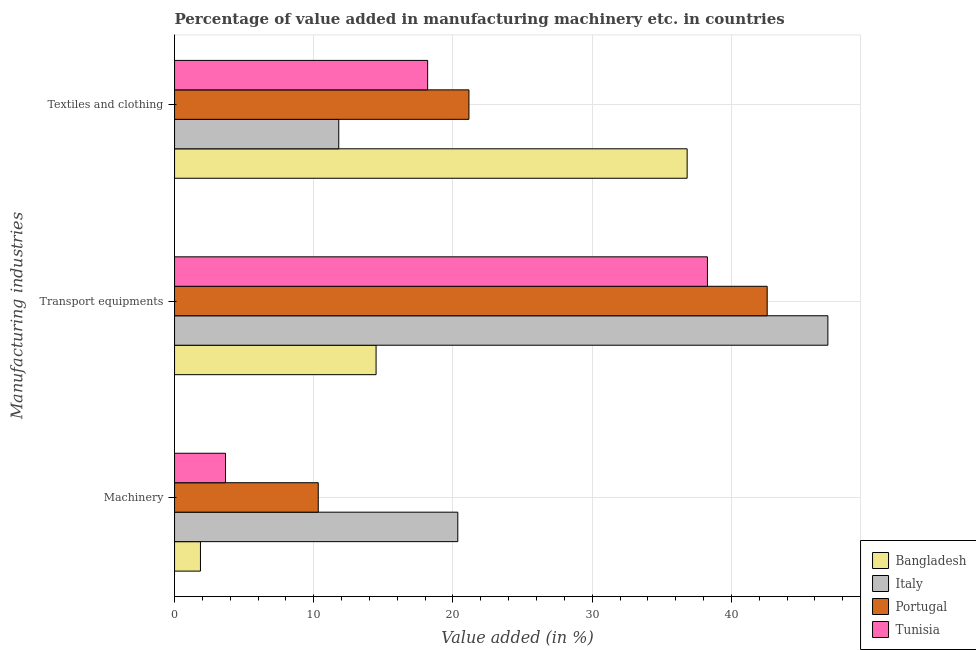How many different coloured bars are there?
Provide a succinct answer. 4. How many bars are there on the 1st tick from the top?
Keep it short and to the point. 4. How many bars are there on the 3rd tick from the bottom?
Provide a short and direct response. 4. What is the label of the 3rd group of bars from the top?
Make the answer very short. Machinery. What is the value added in manufacturing transport equipments in Italy?
Your answer should be very brief. 46.93. Across all countries, what is the maximum value added in manufacturing textile and clothing?
Give a very brief answer. 36.82. Across all countries, what is the minimum value added in manufacturing transport equipments?
Make the answer very short. 14.48. In which country was the value added in manufacturing machinery maximum?
Offer a very short reply. Italy. In which country was the value added in manufacturing textile and clothing minimum?
Give a very brief answer. Italy. What is the total value added in manufacturing textile and clothing in the graph?
Make the answer very short. 87.94. What is the difference between the value added in manufacturing transport equipments in Italy and that in Tunisia?
Offer a very short reply. 8.65. What is the difference between the value added in manufacturing machinery in Italy and the value added in manufacturing transport equipments in Tunisia?
Offer a terse response. -17.93. What is the average value added in manufacturing textile and clothing per country?
Provide a succinct answer. 21.98. What is the difference between the value added in manufacturing machinery and value added in manufacturing transport equipments in Italy?
Offer a very short reply. -26.58. What is the ratio of the value added in manufacturing machinery in Italy to that in Tunisia?
Give a very brief answer. 5.56. Is the value added in manufacturing machinery in Portugal less than that in Bangladesh?
Give a very brief answer. No. What is the difference between the highest and the second highest value added in manufacturing transport equipments?
Make the answer very short. 4.36. What is the difference between the highest and the lowest value added in manufacturing machinery?
Your response must be concise. 18.48. In how many countries, is the value added in manufacturing textile and clothing greater than the average value added in manufacturing textile and clothing taken over all countries?
Offer a very short reply. 1. What does the 2nd bar from the top in Textiles and clothing represents?
Provide a short and direct response. Portugal. What does the 4th bar from the bottom in Textiles and clothing represents?
Provide a succinct answer. Tunisia. Is it the case that in every country, the sum of the value added in manufacturing machinery and value added in manufacturing transport equipments is greater than the value added in manufacturing textile and clothing?
Your answer should be very brief. No. How many countries are there in the graph?
Offer a terse response. 4. Does the graph contain grids?
Offer a terse response. Yes. How many legend labels are there?
Ensure brevity in your answer.  4. What is the title of the graph?
Your answer should be compact. Percentage of value added in manufacturing machinery etc. in countries. Does "Seychelles" appear as one of the legend labels in the graph?
Provide a succinct answer. No. What is the label or title of the X-axis?
Offer a terse response. Value added (in %). What is the label or title of the Y-axis?
Provide a succinct answer. Manufacturing industries. What is the Value added (in %) in Bangladesh in Machinery?
Offer a very short reply. 1.86. What is the Value added (in %) of Italy in Machinery?
Provide a short and direct response. 20.34. What is the Value added (in %) of Portugal in Machinery?
Your response must be concise. 10.32. What is the Value added (in %) in Tunisia in Machinery?
Make the answer very short. 3.66. What is the Value added (in %) of Bangladesh in Transport equipments?
Provide a short and direct response. 14.48. What is the Value added (in %) of Italy in Transport equipments?
Provide a short and direct response. 46.93. What is the Value added (in %) of Portugal in Transport equipments?
Your answer should be compact. 42.57. What is the Value added (in %) in Tunisia in Transport equipments?
Offer a very short reply. 38.28. What is the Value added (in %) of Bangladesh in Textiles and clothing?
Your answer should be compact. 36.82. What is the Value added (in %) of Italy in Textiles and clothing?
Ensure brevity in your answer.  11.79. What is the Value added (in %) in Portugal in Textiles and clothing?
Your answer should be compact. 21.15. What is the Value added (in %) in Tunisia in Textiles and clothing?
Ensure brevity in your answer.  18.18. Across all Manufacturing industries, what is the maximum Value added (in %) in Bangladesh?
Offer a very short reply. 36.82. Across all Manufacturing industries, what is the maximum Value added (in %) of Italy?
Provide a short and direct response. 46.93. Across all Manufacturing industries, what is the maximum Value added (in %) of Portugal?
Keep it short and to the point. 42.57. Across all Manufacturing industries, what is the maximum Value added (in %) of Tunisia?
Offer a terse response. 38.28. Across all Manufacturing industries, what is the minimum Value added (in %) in Bangladesh?
Provide a succinct answer. 1.86. Across all Manufacturing industries, what is the minimum Value added (in %) in Italy?
Keep it short and to the point. 11.79. Across all Manufacturing industries, what is the minimum Value added (in %) in Portugal?
Offer a very short reply. 10.32. Across all Manufacturing industries, what is the minimum Value added (in %) in Tunisia?
Provide a succinct answer. 3.66. What is the total Value added (in %) of Bangladesh in the graph?
Your response must be concise. 53.15. What is the total Value added (in %) of Italy in the graph?
Ensure brevity in your answer.  79.07. What is the total Value added (in %) of Portugal in the graph?
Ensure brevity in your answer.  74.04. What is the total Value added (in %) of Tunisia in the graph?
Your response must be concise. 60.12. What is the difference between the Value added (in %) in Bangladesh in Machinery and that in Transport equipments?
Offer a terse response. -12.62. What is the difference between the Value added (in %) in Italy in Machinery and that in Transport equipments?
Your answer should be compact. -26.58. What is the difference between the Value added (in %) in Portugal in Machinery and that in Transport equipments?
Give a very brief answer. -32.25. What is the difference between the Value added (in %) in Tunisia in Machinery and that in Transport equipments?
Offer a terse response. -34.61. What is the difference between the Value added (in %) in Bangladesh in Machinery and that in Textiles and clothing?
Offer a terse response. -34.96. What is the difference between the Value added (in %) of Italy in Machinery and that in Textiles and clothing?
Offer a terse response. 8.55. What is the difference between the Value added (in %) of Portugal in Machinery and that in Textiles and clothing?
Keep it short and to the point. -10.82. What is the difference between the Value added (in %) of Tunisia in Machinery and that in Textiles and clothing?
Your answer should be very brief. -14.52. What is the difference between the Value added (in %) in Bangladesh in Transport equipments and that in Textiles and clothing?
Keep it short and to the point. -22.34. What is the difference between the Value added (in %) of Italy in Transport equipments and that in Textiles and clothing?
Ensure brevity in your answer.  35.13. What is the difference between the Value added (in %) in Portugal in Transport equipments and that in Textiles and clothing?
Keep it short and to the point. 21.42. What is the difference between the Value added (in %) of Tunisia in Transport equipments and that in Textiles and clothing?
Keep it short and to the point. 20.1. What is the difference between the Value added (in %) of Bangladesh in Machinery and the Value added (in %) of Italy in Transport equipments?
Offer a very short reply. -45.07. What is the difference between the Value added (in %) in Bangladesh in Machinery and the Value added (in %) in Portugal in Transport equipments?
Offer a terse response. -40.71. What is the difference between the Value added (in %) of Bangladesh in Machinery and the Value added (in %) of Tunisia in Transport equipments?
Your answer should be very brief. -36.42. What is the difference between the Value added (in %) of Italy in Machinery and the Value added (in %) of Portugal in Transport equipments?
Give a very brief answer. -22.22. What is the difference between the Value added (in %) in Italy in Machinery and the Value added (in %) in Tunisia in Transport equipments?
Keep it short and to the point. -17.93. What is the difference between the Value added (in %) of Portugal in Machinery and the Value added (in %) of Tunisia in Transport equipments?
Offer a very short reply. -27.95. What is the difference between the Value added (in %) in Bangladesh in Machinery and the Value added (in %) in Italy in Textiles and clothing?
Give a very brief answer. -9.93. What is the difference between the Value added (in %) in Bangladesh in Machinery and the Value added (in %) in Portugal in Textiles and clothing?
Keep it short and to the point. -19.29. What is the difference between the Value added (in %) in Bangladesh in Machinery and the Value added (in %) in Tunisia in Textiles and clothing?
Ensure brevity in your answer.  -16.32. What is the difference between the Value added (in %) in Italy in Machinery and the Value added (in %) in Portugal in Textiles and clothing?
Make the answer very short. -0.8. What is the difference between the Value added (in %) in Italy in Machinery and the Value added (in %) in Tunisia in Textiles and clothing?
Provide a succinct answer. 2.17. What is the difference between the Value added (in %) of Portugal in Machinery and the Value added (in %) of Tunisia in Textiles and clothing?
Give a very brief answer. -7.86. What is the difference between the Value added (in %) of Bangladesh in Transport equipments and the Value added (in %) of Italy in Textiles and clothing?
Ensure brevity in your answer.  2.68. What is the difference between the Value added (in %) of Bangladesh in Transport equipments and the Value added (in %) of Portugal in Textiles and clothing?
Ensure brevity in your answer.  -6.67. What is the difference between the Value added (in %) of Bangladesh in Transport equipments and the Value added (in %) of Tunisia in Textiles and clothing?
Make the answer very short. -3.7. What is the difference between the Value added (in %) in Italy in Transport equipments and the Value added (in %) in Portugal in Textiles and clothing?
Offer a terse response. 25.78. What is the difference between the Value added (in %) of Italy in Transport equipments and the Value added (in %) of Tunisia in Textiles and clothing?
Keep it short and to the point. 28.75. What is the difference between the Value added (in %) in Portugal in Transport equipments and the Value added (in %) in Tunisia in Textiles and clothing?
Provide a succinct answer. 24.39. What is the average Value added (in %) of Bangladesh per Manufacturing industries?
Provide a succinct answer. 17.72. What is the average Value added (in %) in Italy per Manufacturing industries?
Make the answer very short. 26.36. What is the average Value added (in %) in Portugal per Manufacturing industries?
Keep it short and to the point. 24.68. What is the average Value added (in %) in Tunisia per Manufacturing industries?
Make the answer very short. 20.04. What is the difference between the Value added (in %) in Bangladesh and Value added (in %) in Italy in Machinery?
Your answer should be compact. -18.48. What is the difference between the Value added (in %) of Bangladesh and Value added (in %) of Portugal in Machinery?
Your response must be concise. -8.46. What is the difference between the Value added (in %) in Bangladesh and Value added (in %) in Tunisia in Machinery?
Offer a terse response. -1.8. What is the difference between the Value added (in %) of Italy and Value added (in %) of Portugal in Machinery?
Your answer should be compact. 10.02. What is the difference between the Value added (in %) of Italy and Value added (in %) of Tunisia in Machinery?
Your response must be concise. 16.68. What is the difference between the Value added (in %) in Portugal and Value added (in %) in Tunisia in Machinery?
Your answer should be compact. 6.66. What is the difference between the Value added (in %) of Bangladesh and Value added (in %) of Italy in Transport equipments?
Make the answer very short. -32.45. What is the difference between the Value added (in %) of Bangladesh and Value added (in %) of Portugal in Transport equipments?
Your answer should be very brief. -28.09. What is the difference between the Value added (in %) of Bangladesh and Value added (in %) of Tunisia in Transport equipments?
Your answer should be compact. -23.8. What is the difference between the Value added (in %) of Italy and Value added (in %) of Portugal in Transport equipments?
Keep it short and to the point. 4.36. What is the difference between the Value added (in %) of Italy and Value added (in %) of Tunisia in Transport equipments?
Your answer should be very brief. 8.65. What is the difference between the Value added (in %) in Portugal and Value added (in %) in Tunisia in Transport equipments?
Make the answer very short. 4.29. What is the difference between the Value added (in %) of Bangladesh and Value added (in %) of Italy in Textiles and clothing?
Provide a succinct answer. 25.02. What is the difference between the Value added (in %) of Bangladesh and Value added (in %) of Portugal in Textiles and clothing?
Give a very brief answer. 15.67. What is the difference between the Value added (in %) of Bangladesh and Value added (in %) of Tunisia in Textiles and clothing?
Your answer should be compact. 18.64. What is the difference between the Value added (in %) in Italy and Value added (in %) in Portugal in Textiles and clothing?
Offer a terse response. -9.35. What is the difference between the Value added (in %) of Italy and Value added (in %) of Tunisia in Textiles and clothing?
Your answer should be very brief. -6.38. What is the difference between the Value added (in %) of Portugal and Value added (in %) of Tunisia in Textiles and clothing?
Ensure brevity in your answer.  2.97. What is the ratio of the Value added (in %) in Bangladesh in Machinery to that in Transport equipments?
Give a very brief answer. 0.13. What is the ratio of the Value added (in %) of Italy in Machinery to that in Transport equipments?
Offer a terse response. 0.43. What is the ratio of the Value added (in %) in Portugal in Machinery to that in Transport equipments?
Your response must be concise. 0.24. What is the ratio of the Value added (in %) of Tunisia in Machinery to that in Transport equipments?
Give a very brief answer. 0.1. What is the ratio of the Value added (in %) of Bangladesh in Machinery to that in Textiles and clothing?
Ensure brevity in your answer.  0.05. What is the ratio of the Value added (in %) in Italy in Machinery to that in Textiles and clothing?
Offer a terse response. 1.73. What is the ratio of the Value added (in %) of Portugal in Machinery to that in Textiles and clothing?
Your response must be concise. 0.49. What is the ratio of the Value added (in %) in Tunisia in Machinery to that in Textiles and clothing?
Your response must be concise. 0.2. What is the ratio of the Value added (in %) in Bangladesh in Transport equipments to that in Textiles and clothing?
Provide a short and direct response. 0.39. What is the ratio of the Value added (in %) of Italy in Transport equipments to that in Textiles and clothing?
Offer a terse response. 3.98. What is the ratio of the Value added (in %) in Portugal in Transport equipments to that in Textiles and clothing?
Your answer should be compact. 2.01. What is the ratio of the Value added (in %) in Tunisia in Transport equipments to that in Textiles and clothing?
Keep it short and to the point. 2.11. What is the difference between the highest and the second highest Value added (in %) of Bangladesh?
Provide a short and direct response. 22.34. What is the difference between the highest and the second highest Value added (in %) of Italy?
Make the answer very short. 26.58. What is the difference between the highest and the second highest Value added (in %) in Portugal?
Offer a very short reply. 21.42. What is the difference between the highest and the second highest Value added (in %) in Tunisia?
Your answer should be compact. 20.1. What is the difference between the highest and the lowest Value added (in %) in Bangladesh?
Provide a succinct answer. 34.96. What is the difference between the highest and the lowest Value added (in %) in Italy?
Give a very brief answer. 35.13. What is the difference between the highest and the lowest Value added (in %) of Portugal?
Your answer should be compact. 32.25. What is the difference between the highest and the lowest Value added (in %) in Tunisia?
Your answer should be very brief. 34.61. 